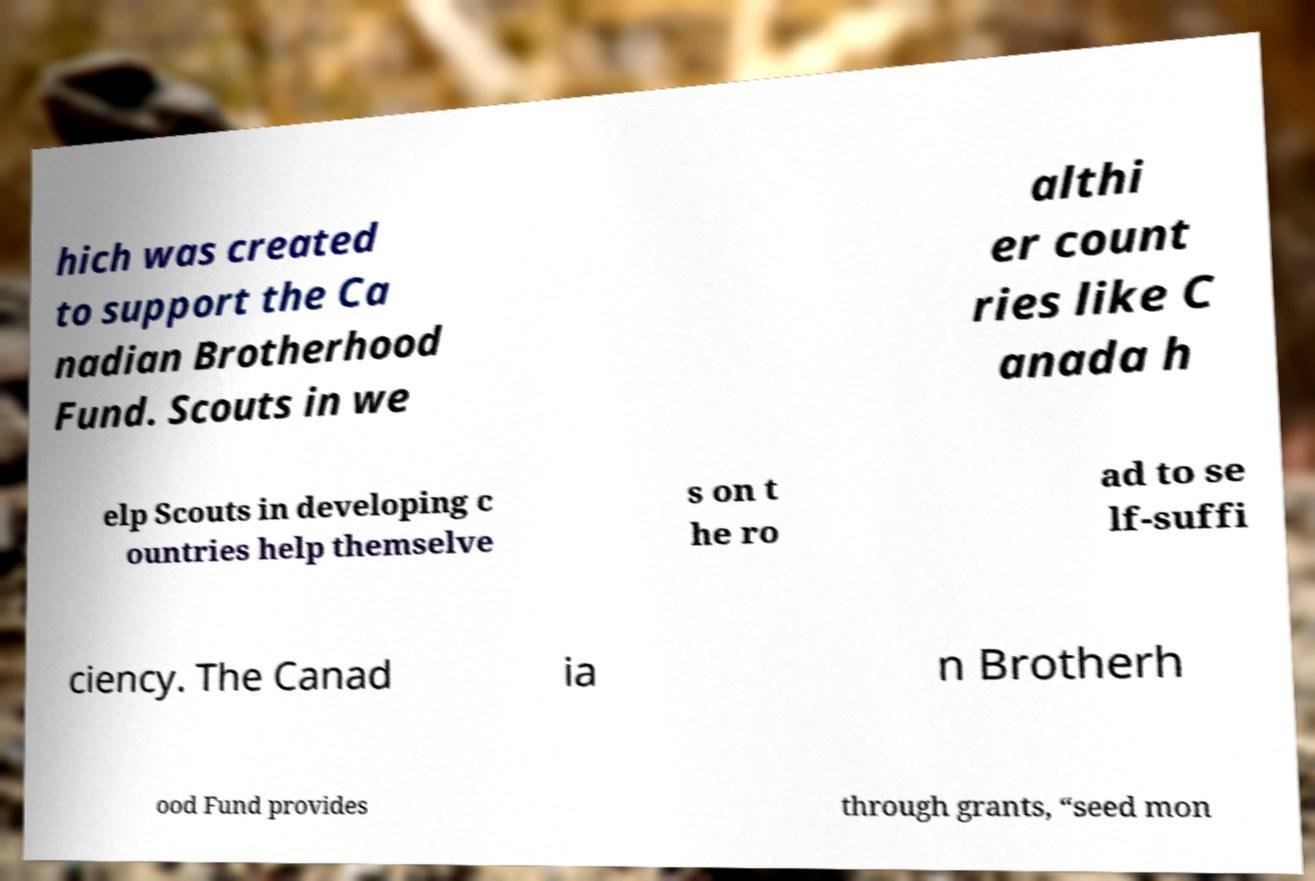Could you assist in decoding the text presented in this image and type it out clearly? hich was created to support the Ca nadian Brotherhood Fund. Scouts in we althi er count ries like C anada h elp Scouts in developing c ountries help themselve s on t he ro ad to se lf-suffi ciency. The Canad ia n Brotherh ood Fund provides through grants, “seed mon 